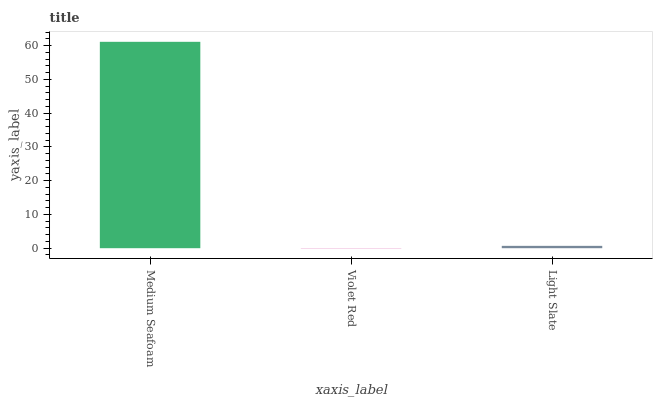Is Violet Red the minimum?
Answer yes or no. Yes. Is Medium Seafoam the maximum?
Answer yes or no. Yes. Is Light Slate the minimum?
Answer yes or no. No. Is Light Slate the maximum?
Answer yes or no. No. Is Light Slate greater than Violet Red?
Answer yes or no. Yes. Is Violet Red less than Light Slate?
Answer yes or no. Yes. Is Violet Red greater than Light Slate?
Answer yes or no. No. Is Light Slate less than Violet Red?
Answer yes or no. No. Is Light Slate the high median?
Answer yes or no. Yes. Is Light Slate the low median?
Answer yes or no. Yes. Is Medium Seafoam the high median?
Answer yes or no. No. Is Medium Seafoam the low median?
Answer yes or no. No. 